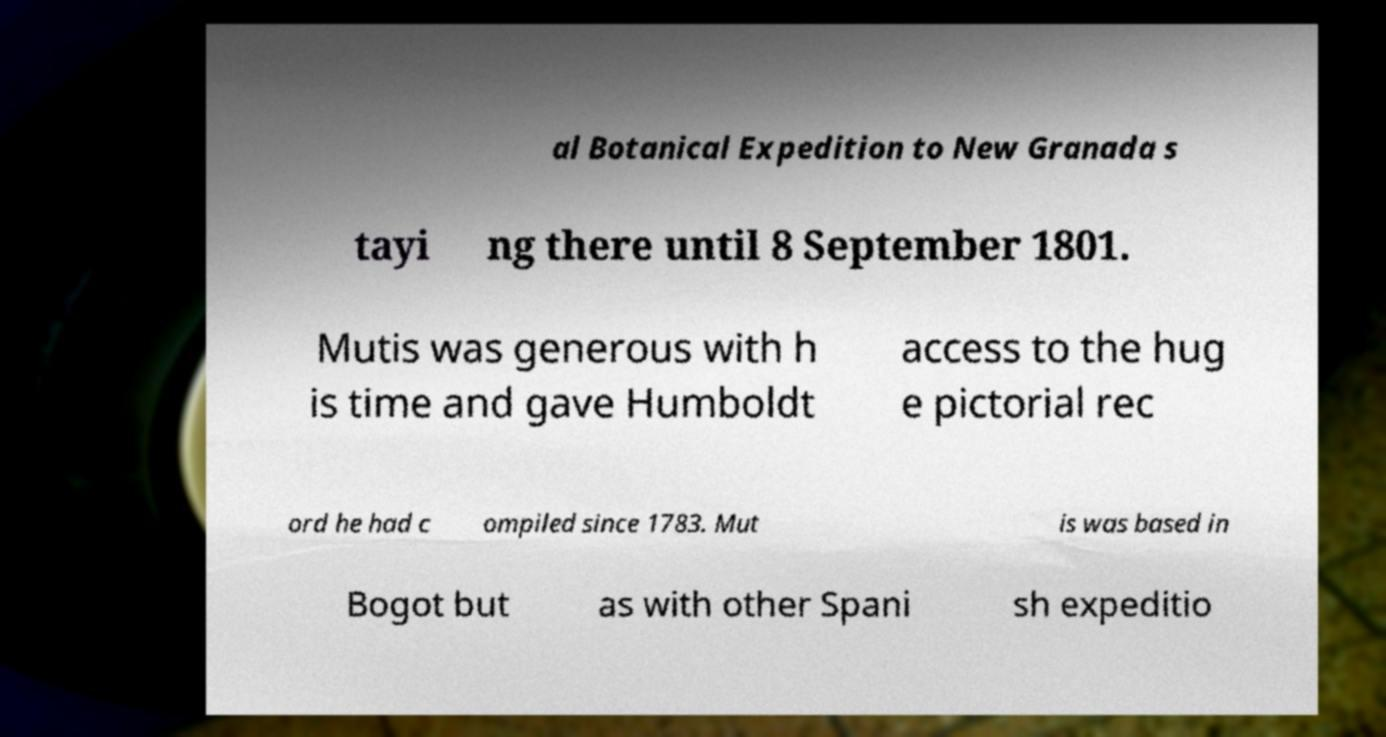What messages or text are displayed in this image? I need them in a readable, typed format. al Botanical Expedition to New Granada s tayi ng there until 8 September 1801. Mutis was generous with h is time and gave Humboldt access to the hug e pictorial rec ord he had c ompiled since 1783. Mut is was based in Bogot but as with other Spani sh expeditio 